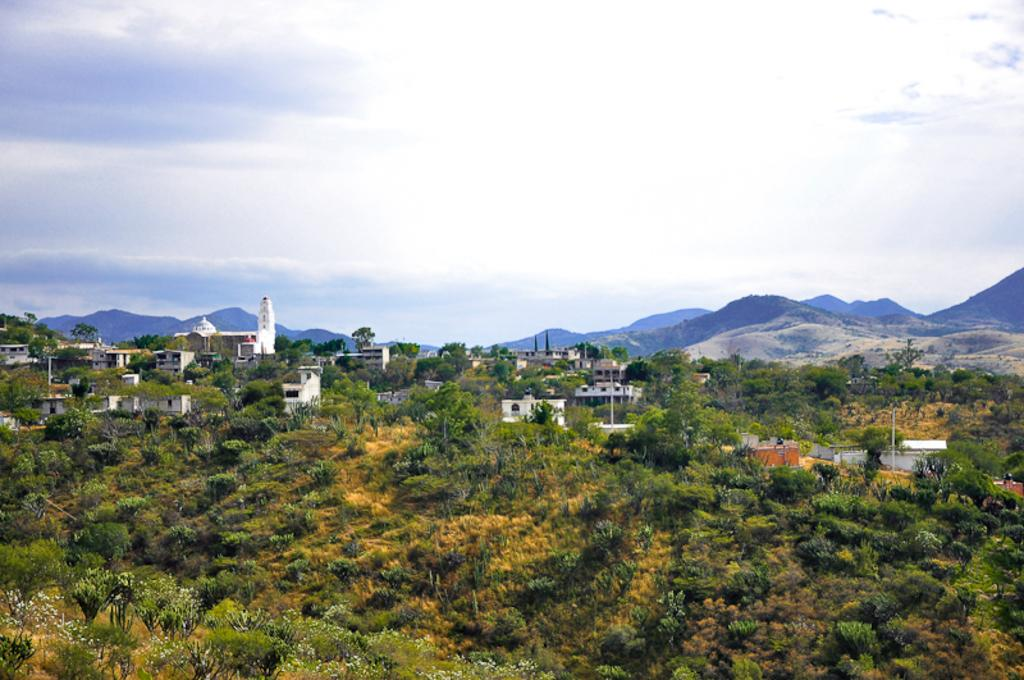What type of structures can be seen in the image? There are many buildings in the image. What type of vegetation is present at the bottom of the image? There are trees at the bottom of the image. What can be seen in the distance in the image? Hills are visible in the background of the image. What is visible above the buildings and trees in the image? The sky is visible in the background of the image. What color is the nose of the person standing in the yard in the image? There is no person or yard present in the image; it features buildings, trees, hills, and the sky. 